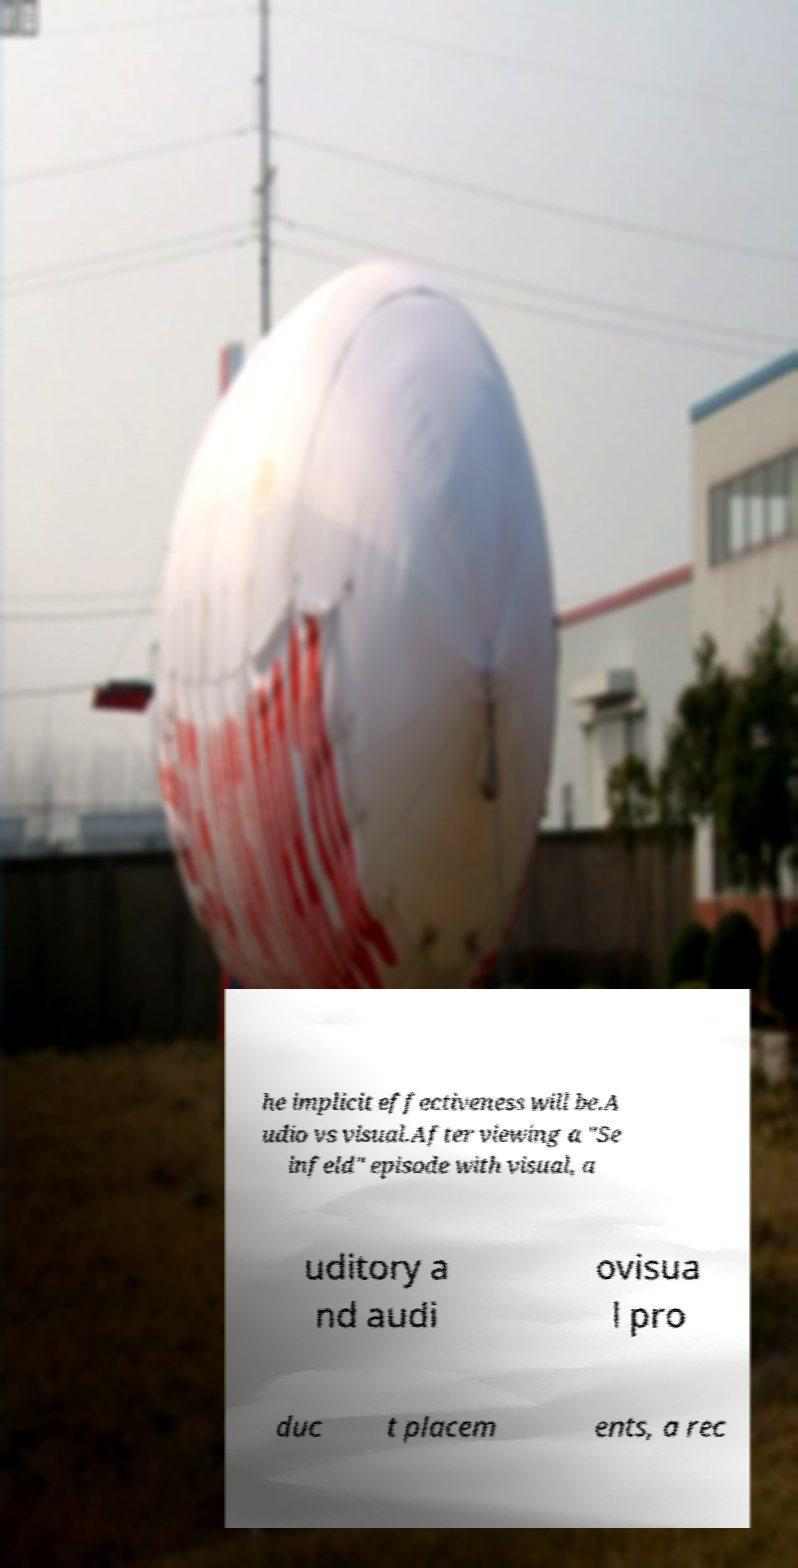Please read and relay the text visible in this image. What does it say? he implicit effectiveness will be.A udio vs visual.After viewing a "Se infeld" episode with visual, a uditory a nd audi ovisua l pro duc t placem ents, a rec 